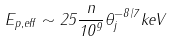Convert formula to latex. <formula><loc_0><loc_0><loc_500><loc_500>E _ { p , e f f } \sim 2 5 \frac { n } { 1 0 ^ { 9 } } \theta _ { j } ^ { - 8 / 7 } k e V</formula> 